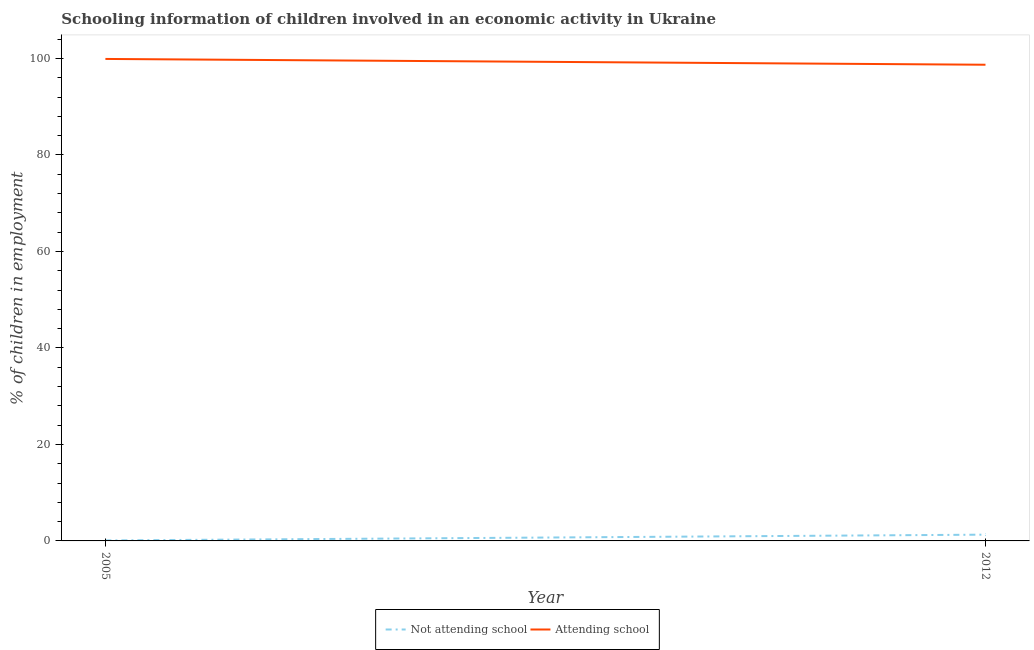Does the line corresponding to percentage of employed children who are attending school intersect with the line corresponding to percentage of employed children who are not attending school?
Your answer should be very brief. No. Is the number of lines equal to the number of legend labels?
Your answer should be compact. Yes. What is the percentage of employed children who are attending school in 2012?
Offer a terse response. 98.7. Across all years, what is the maximum percentage of employed children who are not attending school?
Ensure brevity in your answer.  1.3. In which year was the percentage of employed children who are attending school maximum?
Provide a short and direct response. 2005. In which year was the percentage of employed children who are not attending school minimum?
Your answer should be very brief. 2005. What is the total percentage of employed children who are attending school in the graph?
Provide a succinct answer. 198.6. What is the difference between the percentage of employed children who are attending school in 2005 and the percentage of employed children who are not attending school in 2012?
Your response must be concise. 98.6. What is the average percentage of employed children who are not attending school per year?
Offer a very short reply. 0.7. In the year 2005, what is the difference between the percentage of employed children who are not attending school and percentage of employed children who are attending school?
Provide a short and direct response. -99.8. In how many years, is the percentage of employed children who are not attending school greater than 36 %?
Your answer should be very brief. 0. What is the ratio of the percentage of employed children who are not attending school in 2005 to that in 2012?
Your response must be concise. 0.08. Is the percentage of employed children who are attending school in 2005 less than that in 2012?
Offer a terse response. No. In how many years, is the percentage of employed children who are attending school greater than the average percentage of employed children who are attending school taken over all years?
Your answer should be very brief. 1. Is the percentage of employed children who are not attending school strictly greater than the percentage of employed children who are attending school over the years?
Give a very brief answer. No. How many lines are there?
Make the answer very short. 2. How many years are there in the graph?
Your response must be concise. 2. Does the graph contain any zero values?
Your answer should be compact. No. Where does the legend appear in the graph?
Your response must be concise. Bottom center. What is the title of the graph?
Make the answer very short. Schooling information of children involved in an economic activity in Ukraine. What is the label or title of the X-axis?
Provide a short and direct response. Year. What is the label or title of the Y-axis?
Give a very brief answer. % of children in employment. What is the % of children in employment of Attending school in 2005?
Offer a terse response. 99.9. What is the % of children in employment of Attending school in 2012?
Offer a terse response. 98.7. Across all years, what is the maximum % of children in employment of Not attending school?
Keep it short and to the point. 1.3. Across all years, what is the maximum % of children in employment in Attending school?
Keep it short and to the point. 99.9. Across all years, what is the minimum % of children in employment in Not attending school?
Your answer should be very brief. 0.1. Across all years, what is the minimum % of children in employment in Attending school?
Offer a very short reply. 98.7. What is the total % of children in employment in Attending school in the graph?
Offer a very short reply. 198.6. What is the difference between the % of children in employment in Attending school in 2005 and that in 2012?
Keep it short and to the point. 1.2. What is the difference between the % of children in employment in Not attending school in 2005 and the % of children in employment in Attending school in 2012?
Keep it short and to the point. -98.6. What is the average % of children in employment in Attending school per year?
Offer a very short reply. 99.3. In the year 2005, what is the difference between the % of children in employment in Not attending school and % of children in employment in Attending school?
Provide a short and direct response. -99.8. In the year 2012, what is the difference between the % of children in employment of Not attending school and % of children in employment of Attending school?
Your response must be concise. -97.4. What is the ratio of the % of children in employment in Not attending school in 2005 to that in 2012?
Offer a terse response. 0.08. What is the ratio of the % of children in employment of Attending school in 2005 to that in 2012?
Your response must be concise. 1.01. What is the difference between the highest and the second highest % of children in employment of Not attending school?
Keep it short and to the point. 1.2. What is the difference between the highest and the second highest % of children in employment in Attending school?
Provide a short and direct response. 1.2. 